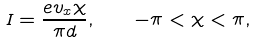Convert formula to latex. <formula><loc_0><loc_0><loc_500><loc_500>I = \frac { e v _ { x } \chi } { \pi d } , \quad - \pi < \chi < \pi ,</formula> 